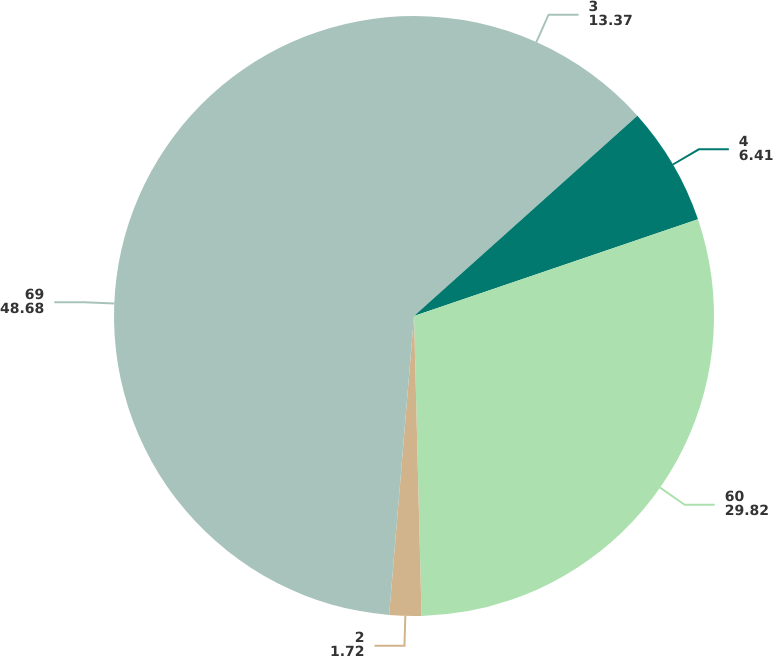Convert chart to OTSL. <chart><loc_0><loc_0><loc_500><loc_500><pie_chart><fcel>3<fcel>4<fcel>60<fcel>2<fcel>69<nl><fcel>13.37%<fcel>6.41%<fcel>29.82%<fcel>1.72%<fcel>48.68%<nl></chart> 